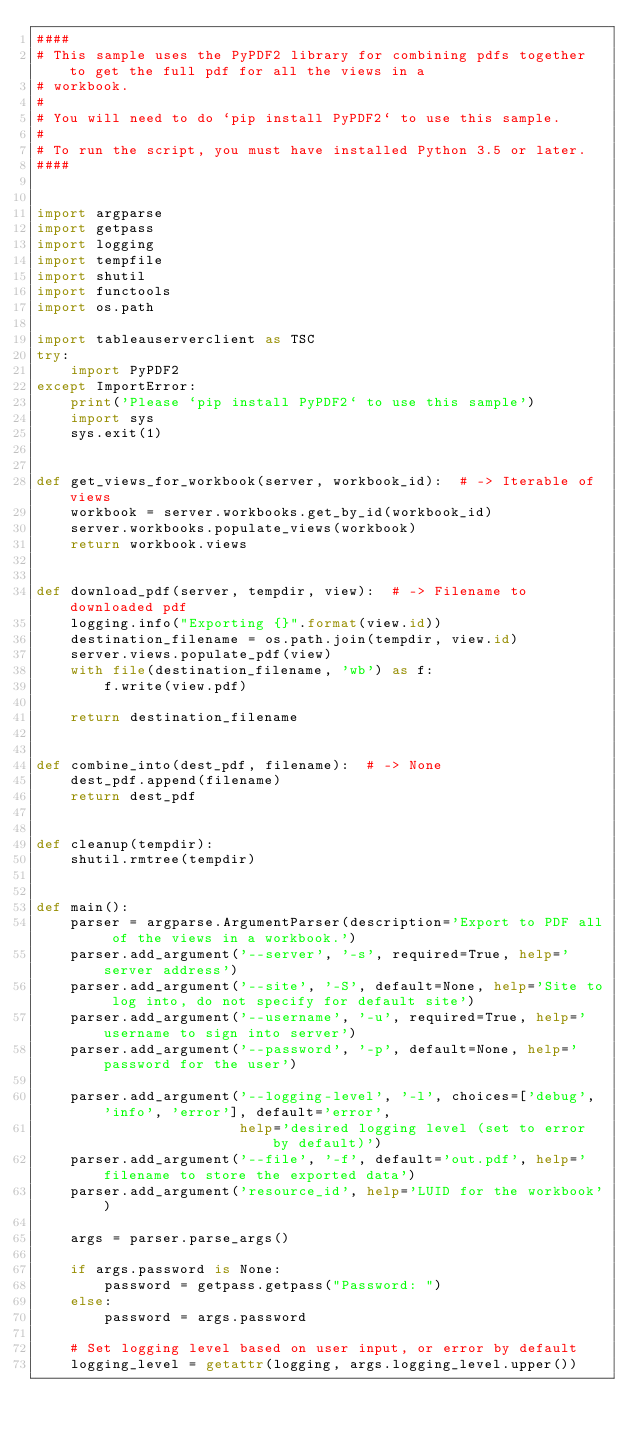Convert code to text. <code><loc_0><loc_0><loc_500><loc_500><_Python_>####
# This sample uses the PyPDF2 library for combining pdfs together to get the full pdf for all the views in a
# workbook.
#
# You will need to do `pip install PyPDF2` to use this sample.
#
# To run the script, you must have installed Python 3.5 or later.
####


import argparse
import getpass
import logging
import tempfile
import shutil
import functools
import os.path

import tableauserverclient as TSC
try:
    import PyPDF2
except ImportError:
    print('Please `pip install PyPDF2` to use this sample')
    import sys
    sys.exit(1)


def get_views_for_workbook(server, workbook_id):  # -> Iterable of views
    workbook = server.workbooks.get_by_id(workbook_id)
    server.workbooks.populate_views(workbook)
    return workbook.views


def download_pdf(server, tempdir, view):  # -> Filename to downloaded pdf
    logging.info("Exporting {}".format(view.id))
    destination_filename = os.path.join(tempdir, view.id)
    server.views.populate_pdf(view)
    with file(destination_filename, 'wb') as f:
        f.write(view.pdf)

    return destination_filename


def combine_into(dest_pdf, filename):  # -> None
    dest_pdf.append(filename)
    return dest_pdf


def cleanup(tempdir):
    shutil.rmtree(tempdir)


def main():
    parser = argparse.ArgumentParser(description='Export to PDF all of the views in a workbook.')
    parser.add_argument('--server', '-s', required=True, help='server address')
    parser.add_argument('--site', '-S', default=None, help='Site to log into, do not specify for default site')
    parser.add_argument('--username', '-u', required=True, help='username to sign into server')
    parser.add_argument('--password', '-p', default=None, help='password for the user')

    parser.add_argument('--logging-level', '-l', choices=['debug', 'info', 'error'], default='error',
                        help='desired logging level (set to error by default)')
    parser.add_argument('--file', '-f', default='out.pdf', help='filename to store the exported data')
    parser.add_argument('resource_id', help='LUID for the workbook')

    args = parser.parse_args()

    if args.password is None:
        password = getpass.getpass("Password: ")
    else:
        password = args.password

    # Set logging level based on user input, or error by default
    logging_level = getattr(logging, args.logging_level.upper())</code> 